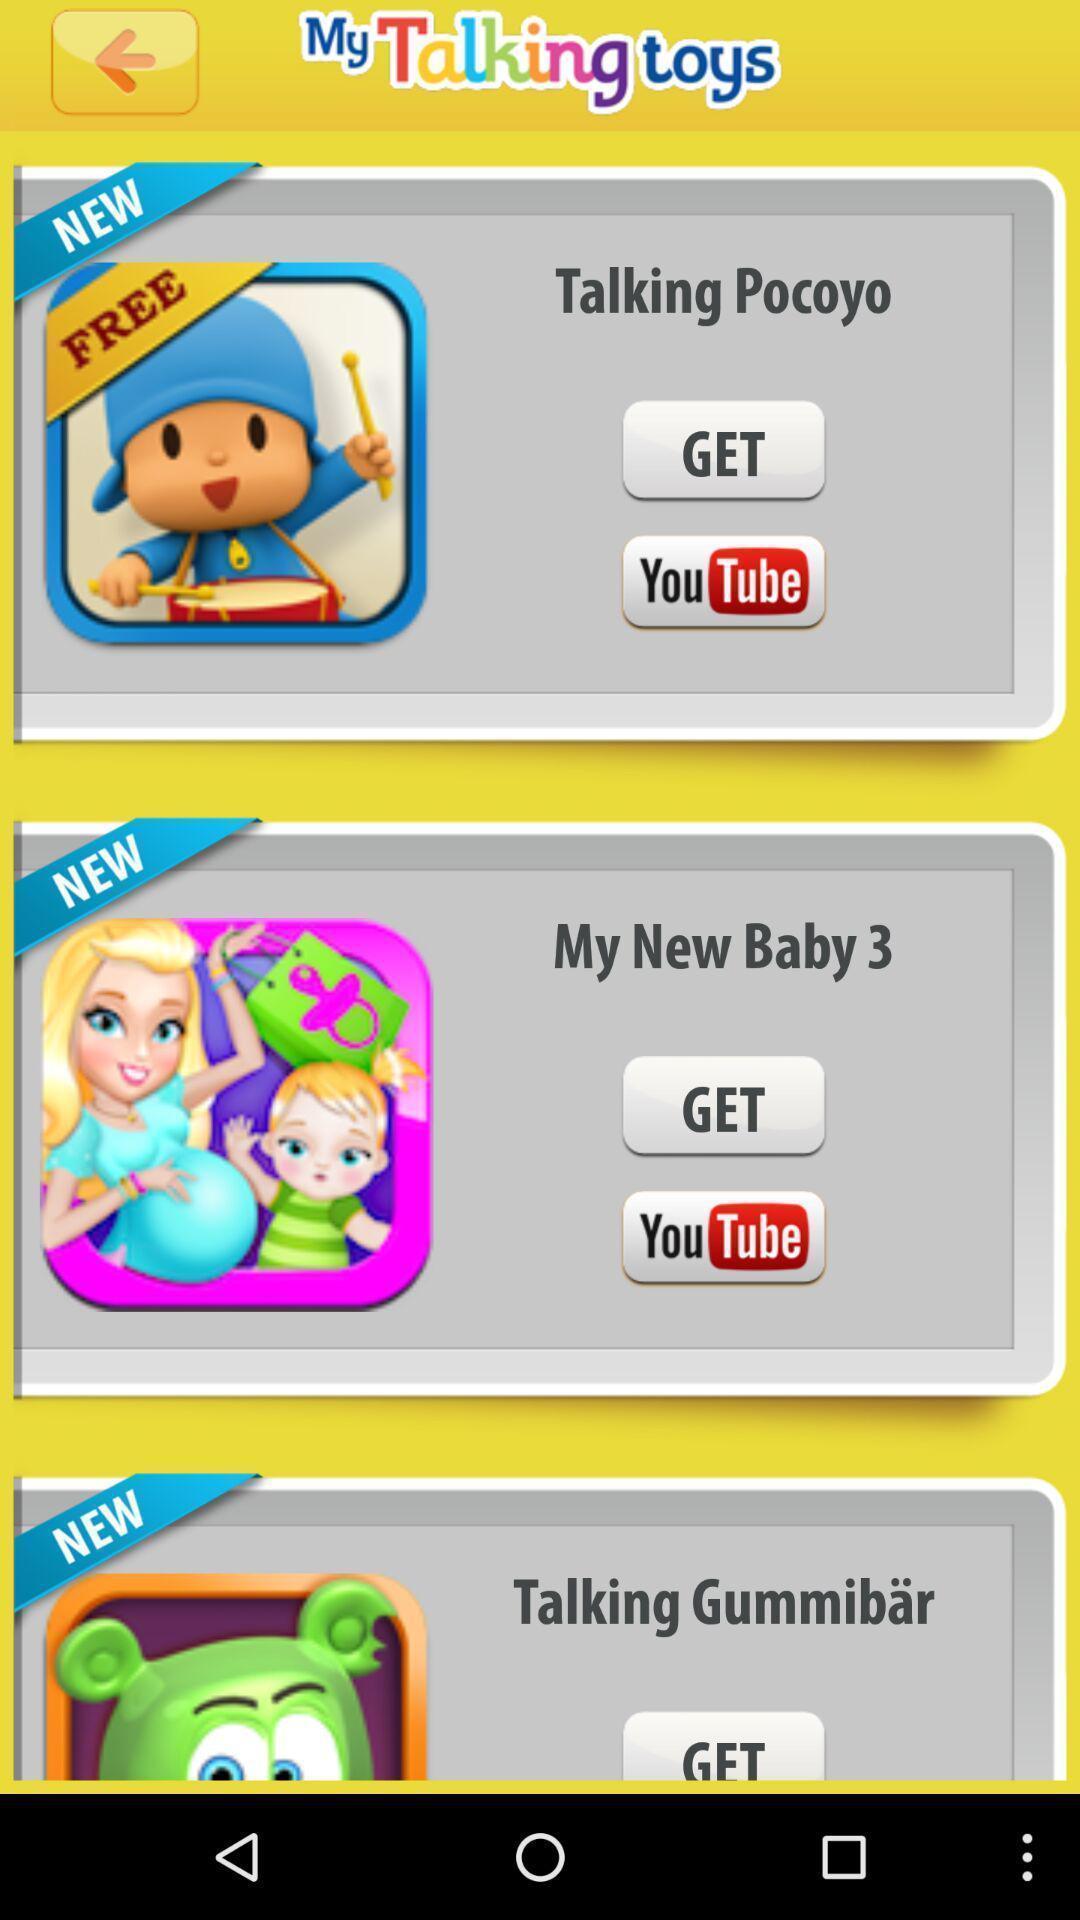Provide a description of this screenshot. Screen displaying the list of advertisements. 